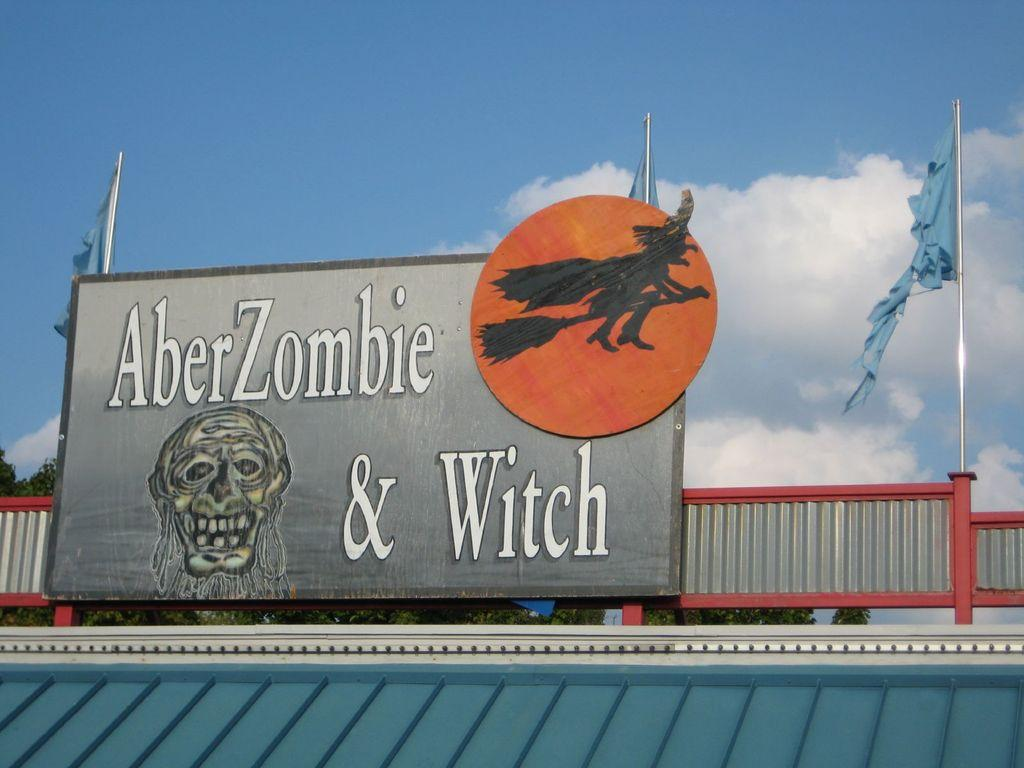<image>
Write a terse but informative summary of the picture. A large sign for AberZombie & Witch on top of a blue roof. 